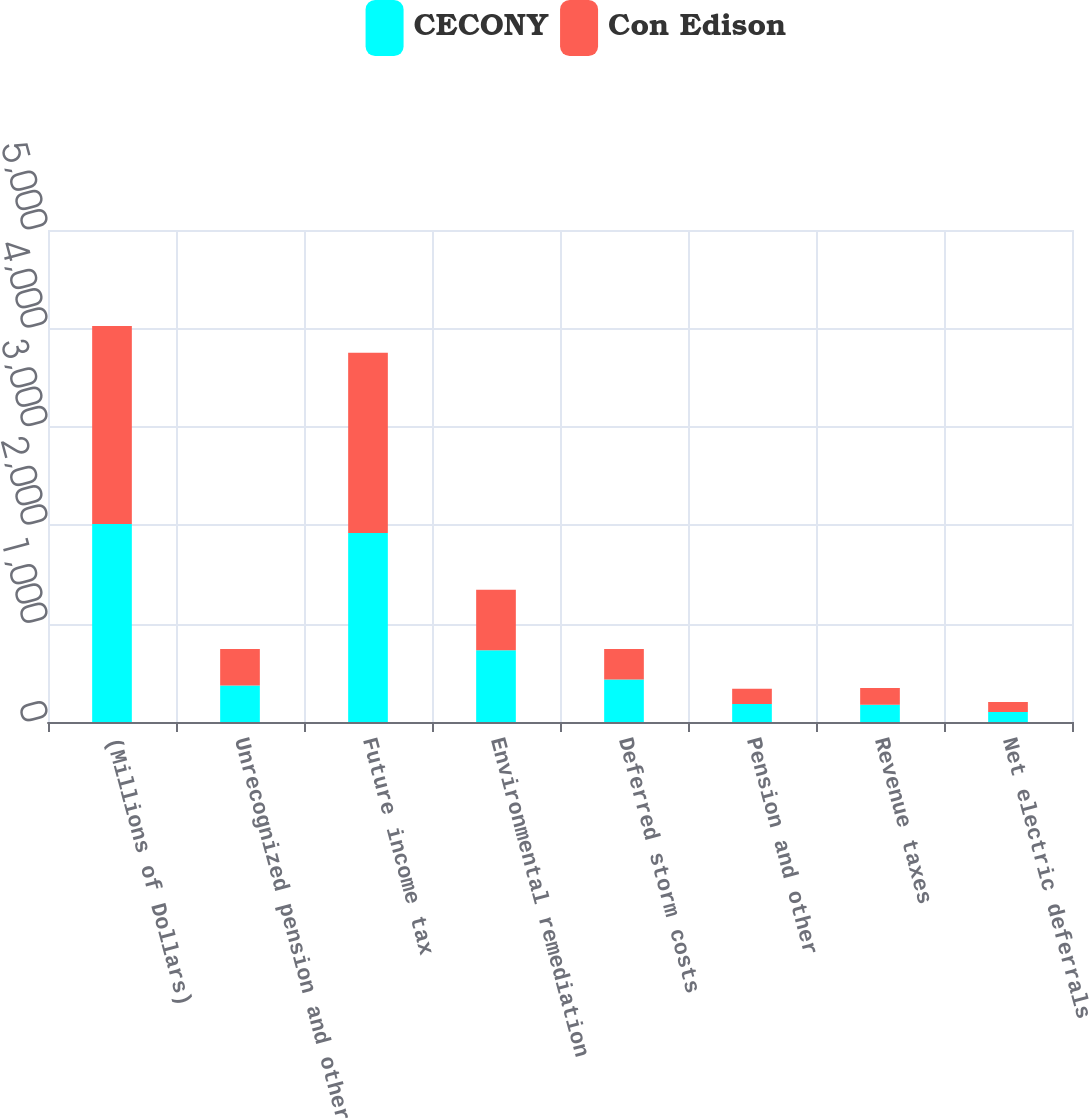Convert chart to OTSL. <chart><loc_0><loc_0><loc_500><loc_500><stacked_bar_chart><ecel><fcel>(Millions of Dollars)<fcel>Unrecognized pension and other<fcel>Future income tax<fcel>Environmental remediation<fcel>Deferred storm costs<fcel>Pension and other<fcel>Revenue taxes<fcel>Net electric deferrals<nl><fcel>CECONY<fcel>2012<fcel>370.5<fcel>1922<fcel>730<fcel>432<fcel>183<fcel>176<fcel>102<nl><fcel>Con Edison<fcel>2012<fcel>370.5<fcel>1831<fcel>615<fcel>309<fcel>154<fcel>170<fcel>102<nl></chart> 